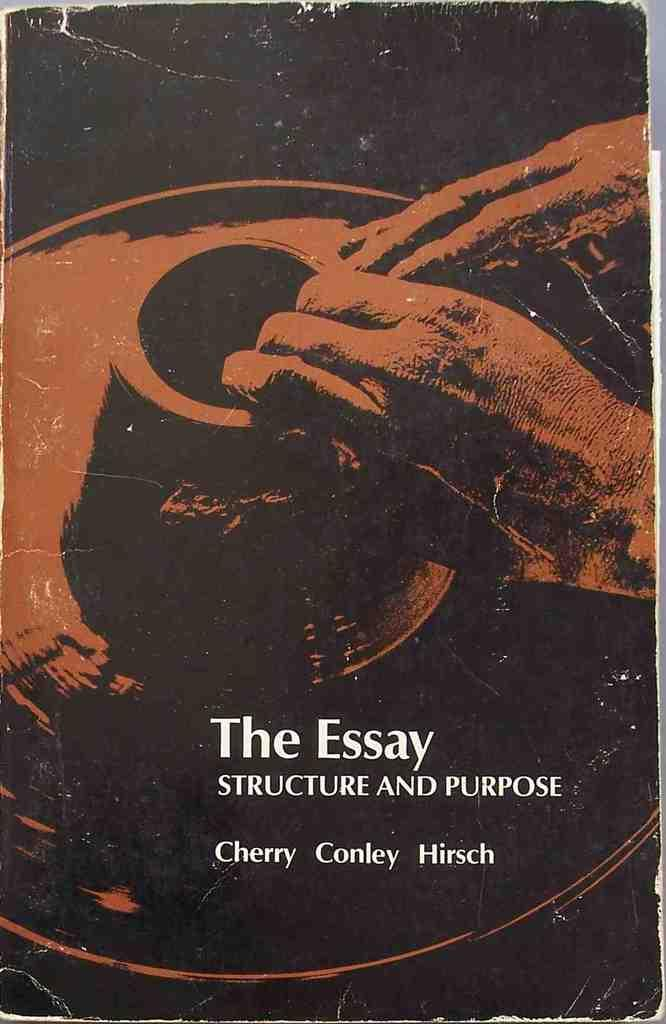<image>
Write a terse but informative summary of the picture. An old book cover titled The Essay Structure and Purpose. 